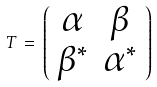<formula> <loc_0><loc_0><loc_500><loc_500>T \, = \, \left ( \begin{array} { c c } \alpha & \beta \\ \beta ^ { * } & \alpha ^ { * } \end{array} \right )</formula> 